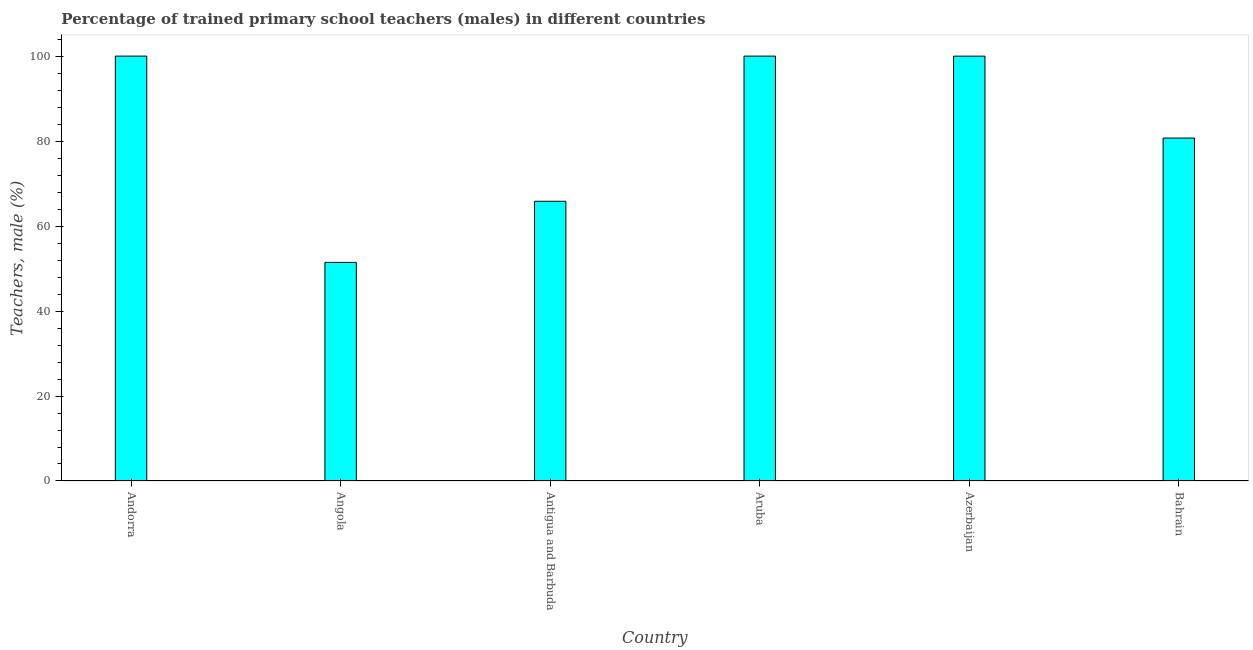What is the title of the graph?
Ensure brevity in your answer.  Percentage of trained primary school teachers (males) in different countries. What is the label or title of the X-axis?
Your response must be concise. Country. What is the label or title of the Y-axis?
Make the answer very short. Teachers, male (%). What is the percentage of trained male teachers in Bahrain?
Give a very brief answer. 80.72. Across all countries, what is the maximum percentage of trained male teachers?
Give a very brief answer. 100. Across all countries, what is the minimum percentage of trained male teachers?
Ensure brevity in your answer.  51.45. In which country was the percentage of trained male teachers maximum?
Offer a terse response. Andorra. In which country was the percentage of trained male teachers minimum?
Keep it short and to the point. Angola. What is the sum of the percentage of trained male teachers?
Offer a very short reply. 498. What is the difference between the percentage of trained male teachers in Angola and Aruba?
Your answer should be very brief. -48.55. What is the average percentage of trained male teachers per country?
Provide a short and direct response. 83. What is the median percentage of trained male teachers?
Offer a very short reply. 90.35. In how many countries, is the percentage of trained male teachers greater than 12 %?
Your answer should be very brief. 6. What is the ratio of the percentage of trained male teachers in Antigua and Barbuda to that in Azerbaijan?
Your response must be concise. 0.66. Is the percentage of trained male teachers in Andorra less than that in Angola?
Make the answer very short. No. Is the difference between the percentage of trained male teachers in Azerbaijan and Bahrain greater than the difference between any two countries?
Provide a short and direct response. No. What is the difference between the highest and the lowest percentage of trained male teachers?
Keep it short and to the point. 48.55. In how many countries, is the percentage of trained male teachers greater than the average percentage of trained male teachers taken over all countries?
Offer a very short reply. 3. How many bars are there?
Provide a short and direct response. 6. How many countries are there in the graph?
Your answer should be compact. 6. What is the difference between two consecutive major ticks on the Y-axis?
Offer a very short reply. 20. What is the Teachers, male (%) of Andorra?
Ensure brevity in your answer.  100. What is the Teachers, male (%) in Angola?
Give a very brief answer. 51.45. What is the Teachers, male (%) in Antigua and Barbuda?
Provide a short and direct response. 65.84. What is the Teachers, male (%) in Aruba?
Your answer should be compact. 100. What is the Teachers, male (%) in Azerbaijan?
Ensure brevity in your answer.  99.99. What is the Teachers, male (%) of Bahrain?
Provide a short and direct response. 80.72. What is the difference between the Teachers, male (%) in Andorra and Angola?
Your answer should be very brief. 48.55. What is the difference between the Teachers, male (%) in Andorra and Antigua and Barbuda?
Your response must be concise. 34.16. What is the difference between the Teachers, male (%) in Andorra and Aruba?
Offer a very short reply. 0. What is the difference between the Teachers, male (%) in Andorra and Azerbaijan?
Provide a short and direct response. 0.01. What is the difference between the Teachers, male (%) in Andorra and Bahrain?
Provide a short and direct response. 19.28. What is the difference between the Teachers, male (%) in Angola and Antigua and Barbuda?
Give a very brief answer. -14.38. What is the difference between the Teachers, male (%) in Angola and Aruba?
Ensure brevity in your answer.  -48.55. What is the difference between the Teachers, male (%) in Angola and Azerbaijan?
Make the answer very short. -48.54. What is the difference between the Teachers, male (%) in Angola and Bahrain?
Your answer should be very brief. -29.27. What is the difference between the Teachers, male (%) in Antigua and Barbuda and Aruba?
Make the answer very short. -34.16. What is the difference between the Teachers, male (%) in Antigua and Barbuda and Azerbaijan?
Give a very brief answer. -34.16. What is the difference between the Teachers, male (%) in Antigua and Barbuda and Bahrain?
Provide a succinct answer. -14.88. What is the difference between the Teachers, male (%) in Aruba and Azerbaijan?
Keep it short and to the point. 0.01. What is the difference between the Teachers, male (%) in Aruba and Bahrain?
Offer a very short reply. 19.28. What is the difference between the Teachers, male (%) in Azerbaijan and Bahrain?
Ensure brevity in your answer.  19.28. What is the ratio of the Teachers, male (%) in Andorra to that in Angola?
Provide a succinct answer. 1.94. What is the ratio of the Teachers, male (%) in Andorra to that in Antigua and Barbuda?
Give a very brief answer. 1.52. What is the ratio of the Teachers, male (%) in Andorra to that in Bahrain?
Your response must be concise. 1.24. What is the ratio of the Teachers, male (%) in Angola to that in Antigua and Barbuda?
Ensure brevity in your answer.  0.78. What is the ratio of the Teachers, male (%) in Angola to that in Aruba?
Your answer should be very brief. 0.52. What is the ratio of the Teachers, male (%) in Angola to that in Azerbaijan?
Your answer should be very brief. 0.52. What is the ratio of the Teachers, male (%) in Angola to that in Bahrain?
Provide a short and direct response. 0.64. What is the ratio of the Teachers, male (%) in Antigua and Barbuda to that in Aruba?
Make the answer very short. 0.66. What is the ratio of the Teachers, male (%) in Antigua and Barbuda to that in Azerbaijan?
Your response must be concise. 0.66. What is the ratio of the Teachers, male (%) in Antigua and Barbuda to that in Bahrain?
Your answer should be very brief. 0.82. What is the ratio of the Teachers, male (%) in Aruba to that in Azerbaijan?
Your answer should be very brief. 1. What is the ratio of the Teachers, male (%) in Aruba to that in Bahrain?
Provide a short and direct response. 1.24. What is the ratio of the Teachers, male (%) in Azerbaijan to that in Bahrain?
Your answer should be compact. 1.24. 